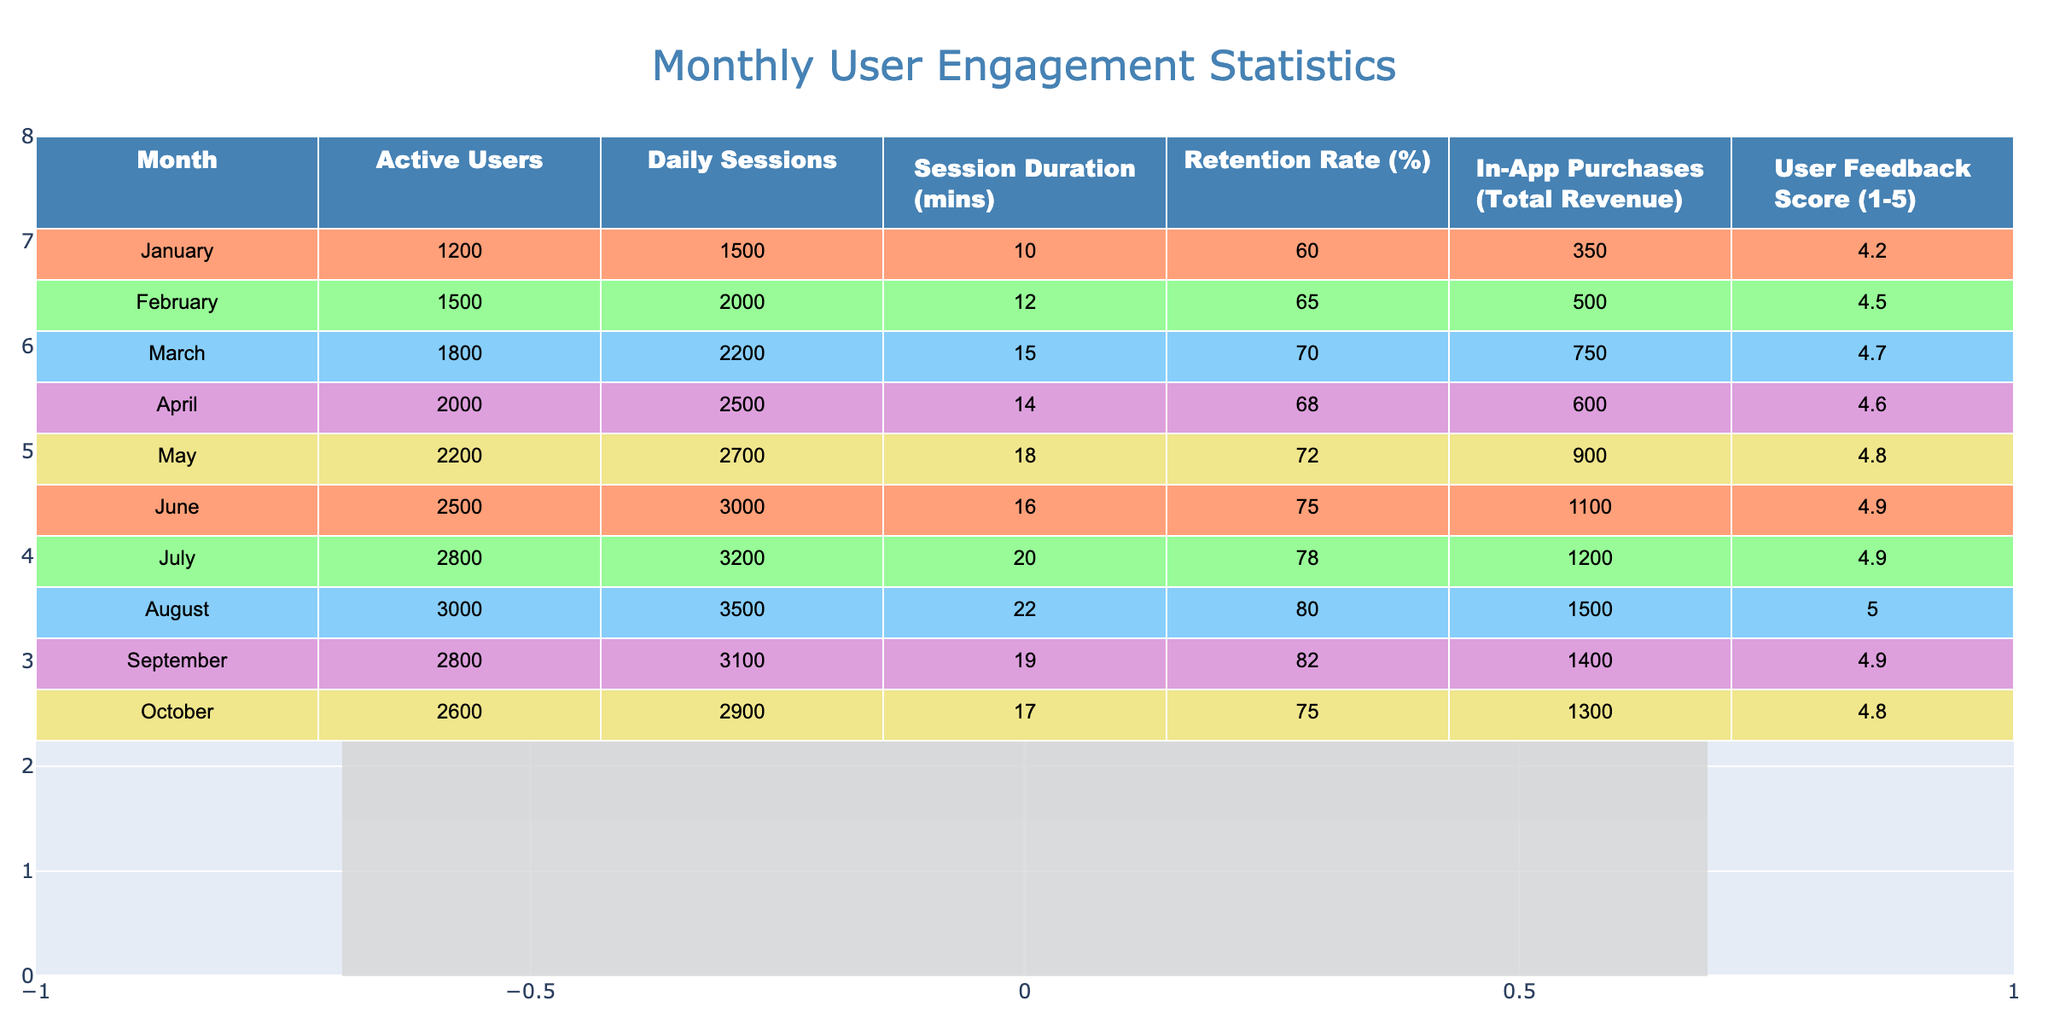What was the retention rate in July? The table indicates that the retention rate for the month of July is listed in the column "Retention Rate (%)" corresponding to July's row. The value is 78%.
Answer: 78% What month had the highest number of active users? By examining the "Active Users" column in the table, we can see that August has the highest value at 3000 active users.
Answer: August What is the total revenue generated from in-app purchases from January to March? To find the total revenue, we sum the "In-App Purchases (Total Revenue)" for January (350), February (500), and March (750). This gives us a total of 350 + 500 + 750 = 1600.
Answer: 1600 What was the average session duration for the first half of the year? To calculate the average session duration from January to June, we take the values from the "Session Duration (mins)" column for these months: 10, 12, 15, 14, 18, 16. The sum is 10 + 12 + 15 + 14 + 18 + 16 = 85, and there are 6 months, so the average is 85 / 6 ≈ 14.17 minutes.
Answer: 14.17 Did the user feedback score ever reach 5.0? Looking through the "User Feedback Score (1-5)" column, we see that August shows a score of 5.0. Thus, the statement is true.
Answer: Yes What was the change in daily sessions from April to October? We find the "Daily Sessions" values for April (2500) and October (2900). The change is calculated as October's daily sessions (2900) minus April's daily sessions (2500), resulting in 2900 - 2500 = 400 sessions increase.
Answer: 400 How many months had a retention rate above 70%? The retention rates listed are 60%, 65%, 70%, 68%, 72%, 75%, 78%, 80%, 82%, and 75%. Examining these, we find that 5 months (from May to September) had a retention rate above 70%.
Answer: 5 What is the median number of active users across all months? First, we list the "Active Users" values: 1200, 1500, 1800, 2000, 2200, 2500, 2800, 3000, 2800, 2600. After sorting these values, the median is the average of the 5th and 6th values, which are 2200 and 2500. Therefore, (2200 + 2500) / 2 = 2350.
Answer: 2350 How does in-app purchase revenue in June compare to that in March? Looking at the values, March had 750 in revenue, while June had 1100. To compare, we calculate that June's revenue is 1100 - 750 = 350 more than March's revenue.
Answer: 350 more than March's revenue 